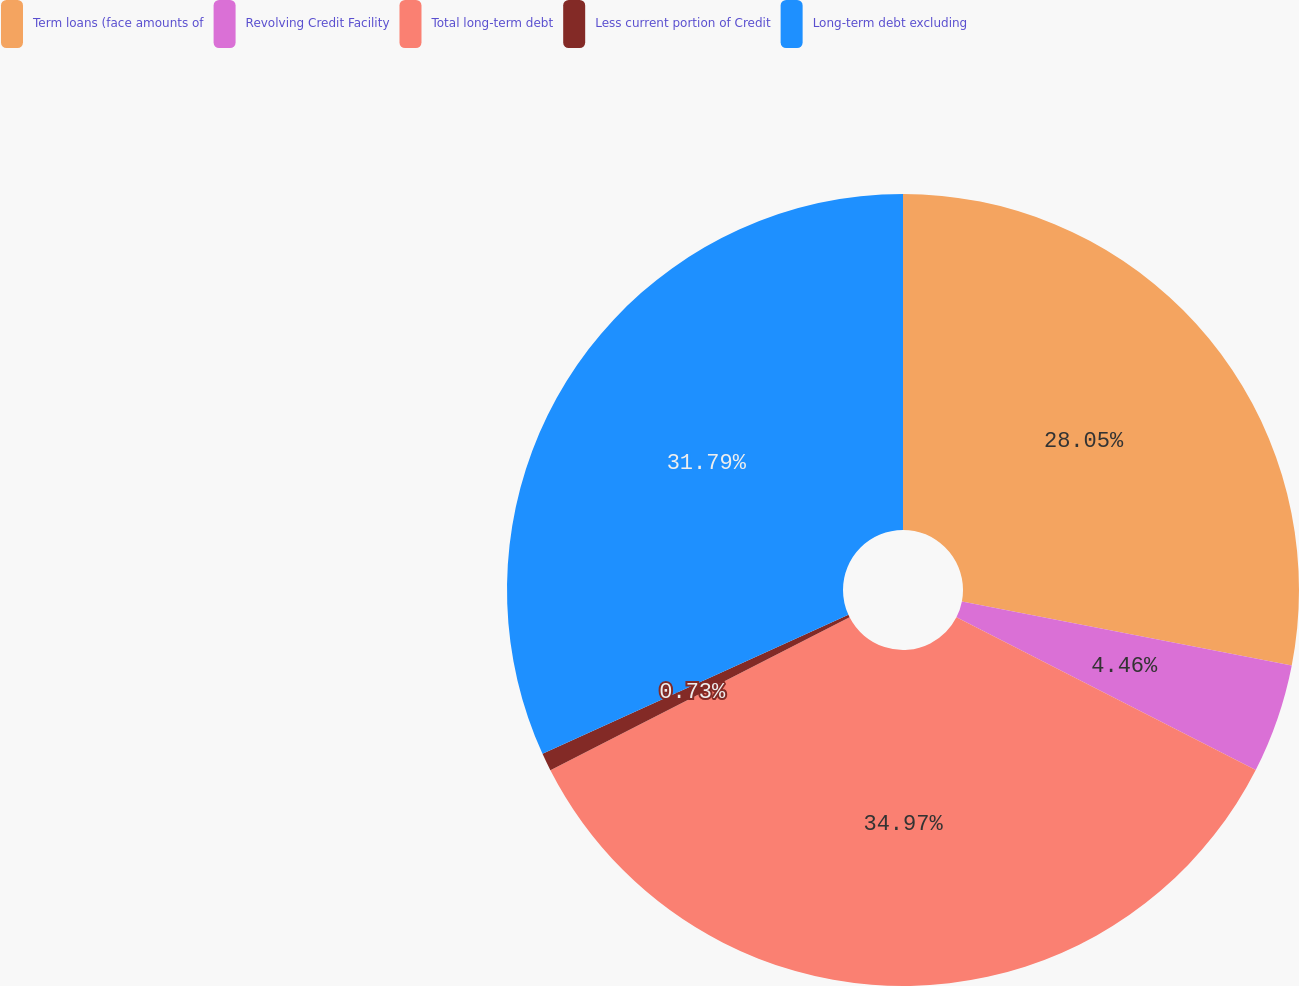<chart> <loc_0><loc_0><loc_500><loc_500><pie_chart><fcel>Term loans (face amounts of<fcel>Revolving Credit Facility<fcel>Total long-term debt<fcel>Less current portion of Credit<fcel>Long-term debt excluding<nl><fcel>28.05%<fcel>4.46%<fcel>34.97%<fcel>0.73%<fcel>31.79%<nl></chart> 